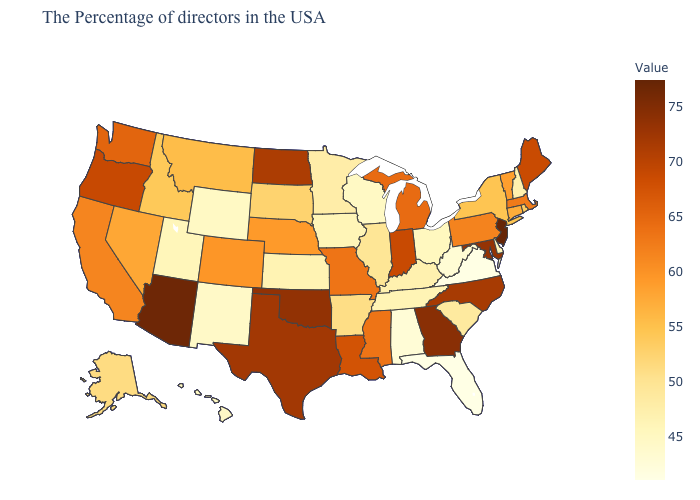Does Minnesota have the highest value in the USA?
Be succinct. No. Which states hav the highest value in the South?
Be succinct. Georgia. Among the states that border Utah , does Idaho have the highest value?
Keep it brief. No. Which states hav the highest value in the South?
Keep it brief. Georgia. Among the states that border Nevada , which have the highest value?
Concise answer only. Arizona. Which states have the lowest value in the USA?
Write a very short answer. Florida. Among the states that border North Dakota , does Montana have the highest value?
Keep it brief. Yes. 